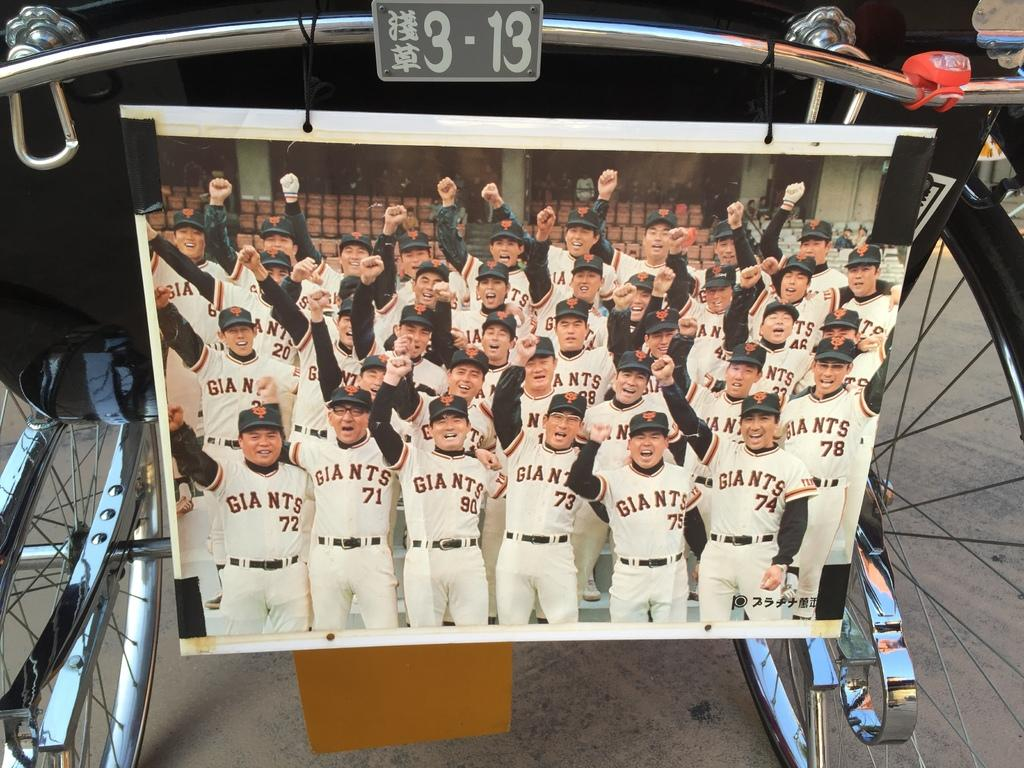Provide a one-sentence caption for the provided image. Photo of a group of Giants photos raising their fists. 